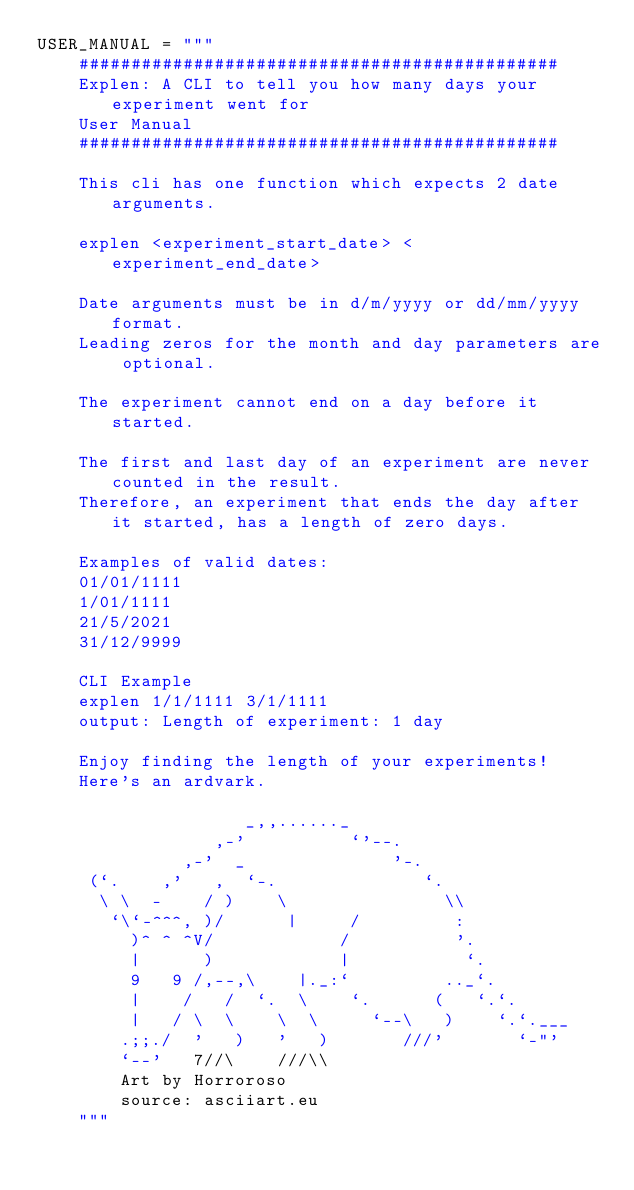<code> <loc_0><loc_0><loc_500><loc_500><_Python_>USER_MANUAL = """
    ##############################################
    Explen: A CLI to tell you how many days your experiment went for
    User Manual
    ##############################################

    This cli has one function which expects 2 date arguments.

    explen <experiment_start_date> <experiment_end_date>

    Date arguments must be in d/m/yyyy or dd/mm/yyyy format.
    Leading zeros for the month and day parameters are optional.

    The experiment cannot end on a day before it started.

    The first and last day of an experiment are never counted in the result.
    Therefore, an experiment that ends the day after it started, has a length of zero days.

    Examples of valid dates:
    01/01/1111
    1/01/1111
    21/5/2021
    31/12/9999

    CLI Example
    explen 1/1/1111 3/1/1111
    output: Length of experiment: 1 day

    Enjoy finding the length of your experiments!
    Here's an ardvark.

                    _,,......_
                 ,-'          `'--.
              ,-'  _              '-.
     (`.    ,'   ,  `-.              `.
      \ \  -    / )    \               \\
       `\`-^^^, )/      |     /         :
         )^ ^ ^V/            /          '.
         |      )            |           `.
         9   9 /,--,\    |._:`         .._`.
         |    /   /  `.  \    `.      (   `.`.
         |   / \  \    \  \     `--\   )    `.`.___
        .;;./  '   )   '   )       ///'       `-"'
        `--'   7//\    ///\\
        Art by Horroroso
        source: asciiart.eu
    """
</code> 